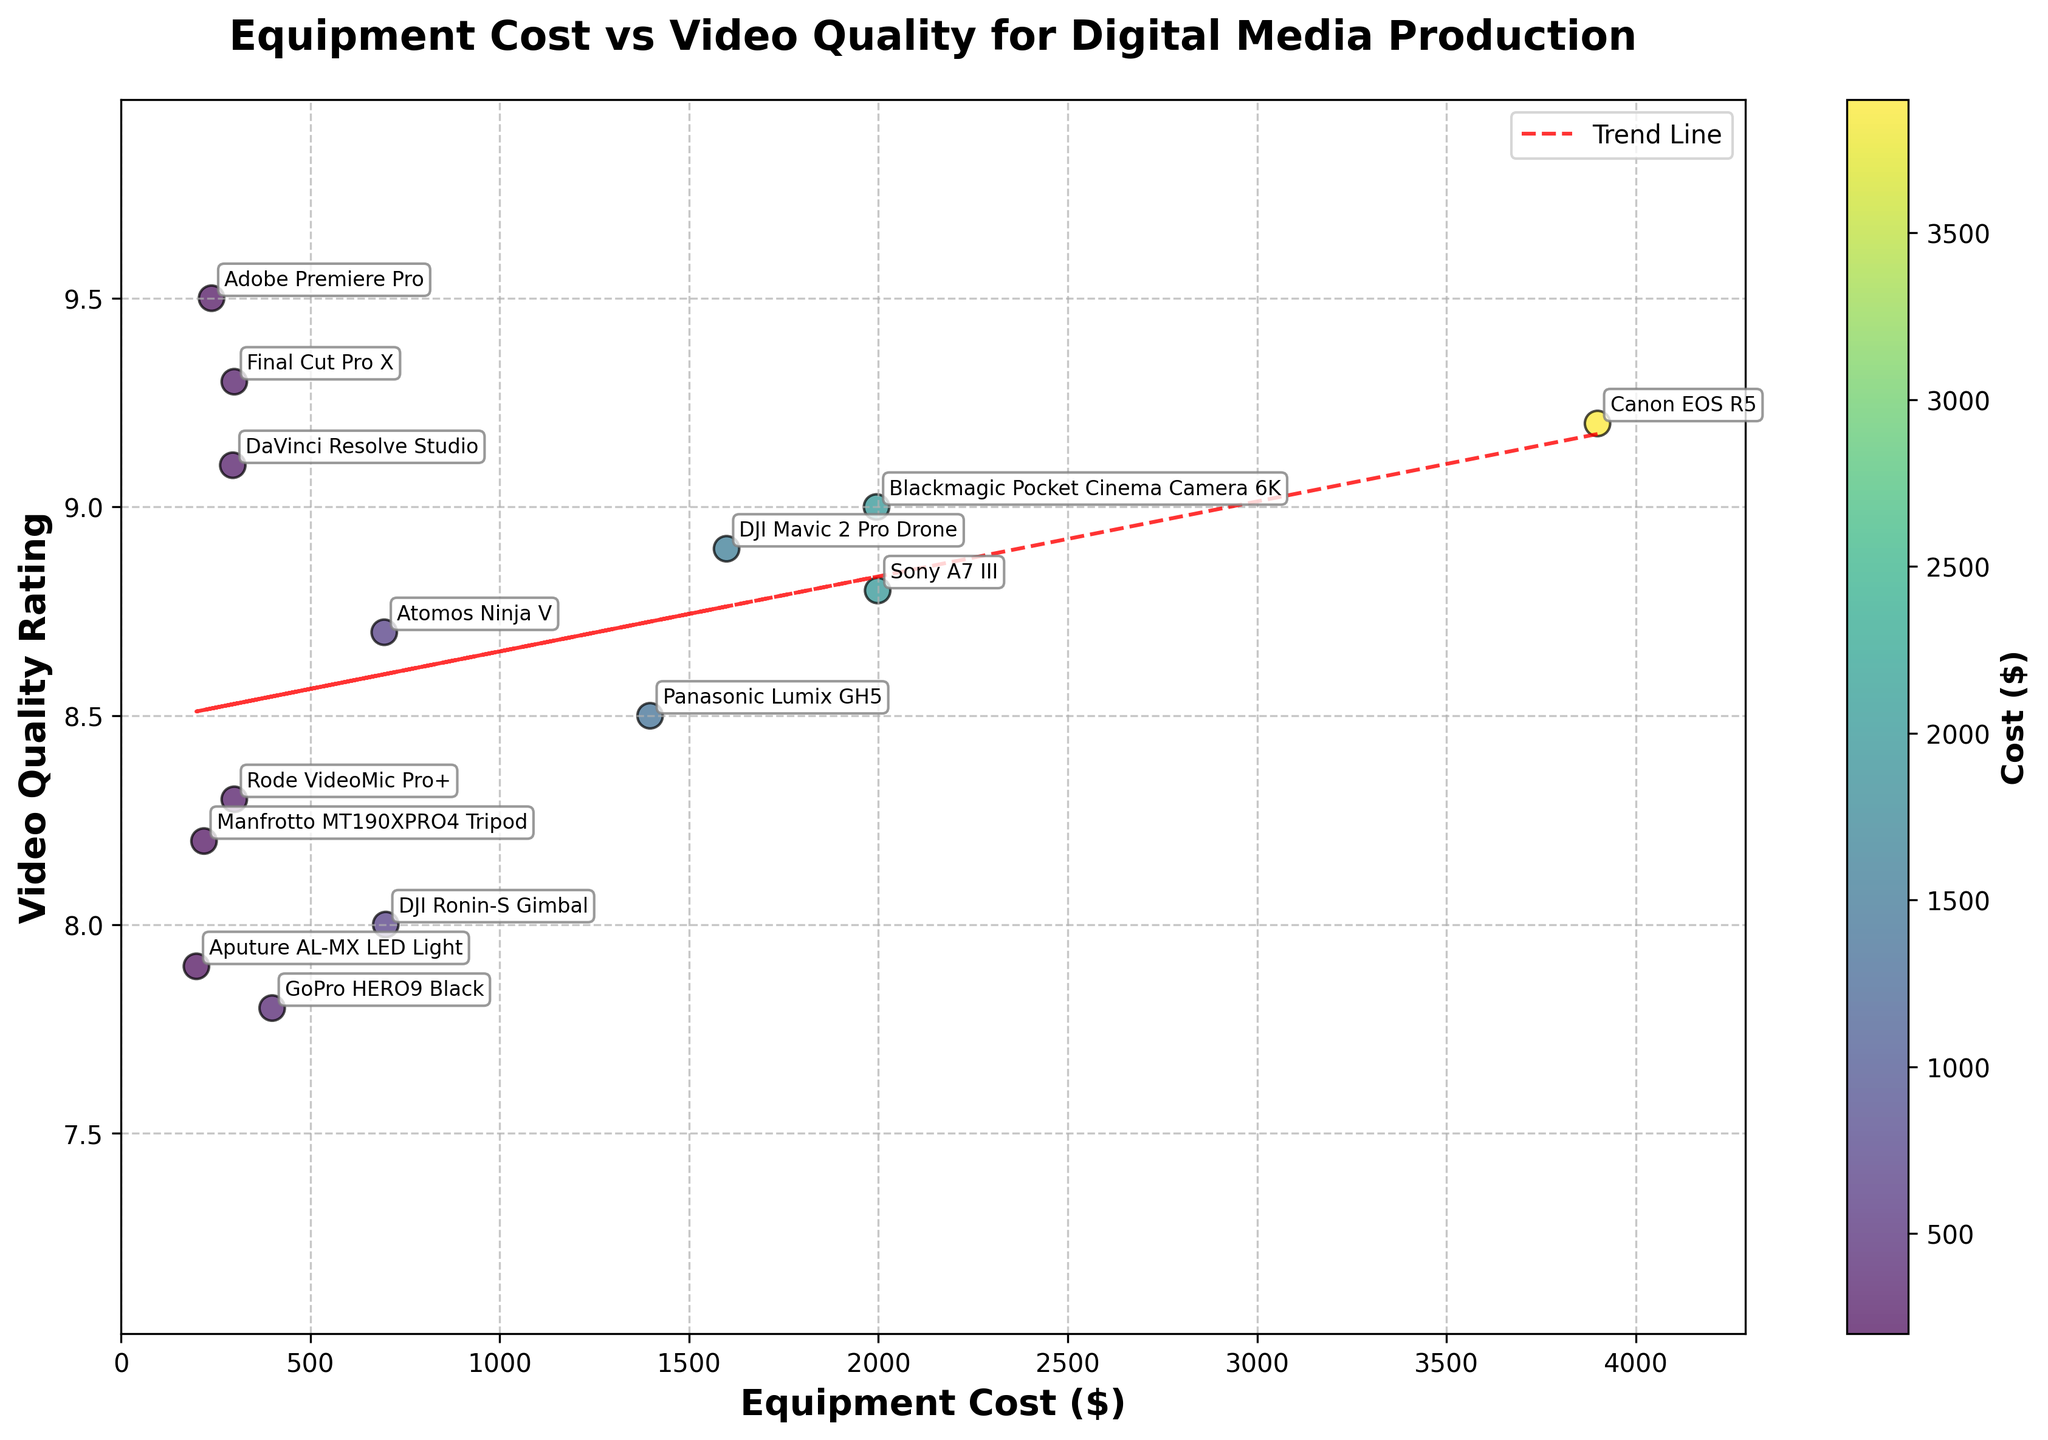What's the title of the figure? The title is usually displayed at the top of the figure and often summarizes what the plot represents. In this case, it's clear and descriptive.
Answer: Equipment Cost vs Video Quality for Digital Media Production How many pieces of equipment are represented in the plot? By counting the number of distinct data points or labels in the scatter plot, you can determine the number of unique pieces of equipment.
Answer: 14 Which equipment has the highest video quality rating and what is its cost? By looking at the scatter plot, identify the highest point on the y-axis. Then check the label and corresponding x-axis value for cost.
Answer: Adobe Premiere Pro, $239 What is the trend between equipment cost and video quality rating? By observing the scatter plot and the added trend line, you can see the overall relationship. If the trend line slopes upward, it indicates a positive relationship; if downward, a negative one.
Answer: Positive trend Which piece of equipment is the most expensive and what is its video quality rating? Locate the point furthest to the right on the x-axis, check its label, and note the corresponding y-axis value.
Answer: Canon EOS R5, 9.2 How does the video quality of the GoPro HERO9 Black compare to that of the DJI Mavic 2 Pro Drone? Find the points corresponding to these pieces of equipment on the plot and compare their y-axis positions.
Answer: The GoPro HERO9 Black has a video quality rating of 7.8, which is lower than the DJI Mavic 2 Pro Drone's 8.9 What is the cost difference between the Blackmagic Pocket Cinema Camera 6K and the Panasonic Lumix GH5? Check the x-axis values for the Blackmagic Pocket Cinema Camera 6K and Panasonic Lumix GH5 and calculate the difference.
Answer: $1995 - $1397 = $598 Which equipment provides the best video quality rating for under $500? Identify points on the scatter plot where the x-axis value (cost) is under $500. Then, compare their y-axis values (video quality ratings).
Answer: Adobe Premiere Pro, 9.5 Does higher cost always guarantee better video quality based on the plotted data? To determine this, look at the entire scatter plot. While there may be a general trend, check for any anomalies where higher cost doesn't necessarily mean better quality.
Answer: No, not always Which two pieces of equipment have a very similar cost but different video quality ratings? Look for points that are close together on the x-axis but have a noticeable difference in their y-axis values.
Answer: Atomos Ninja V ($695) and DJI Ronin-S Gimbal ($699): different video quality ratings of 8.7 and 8.0, respectively 